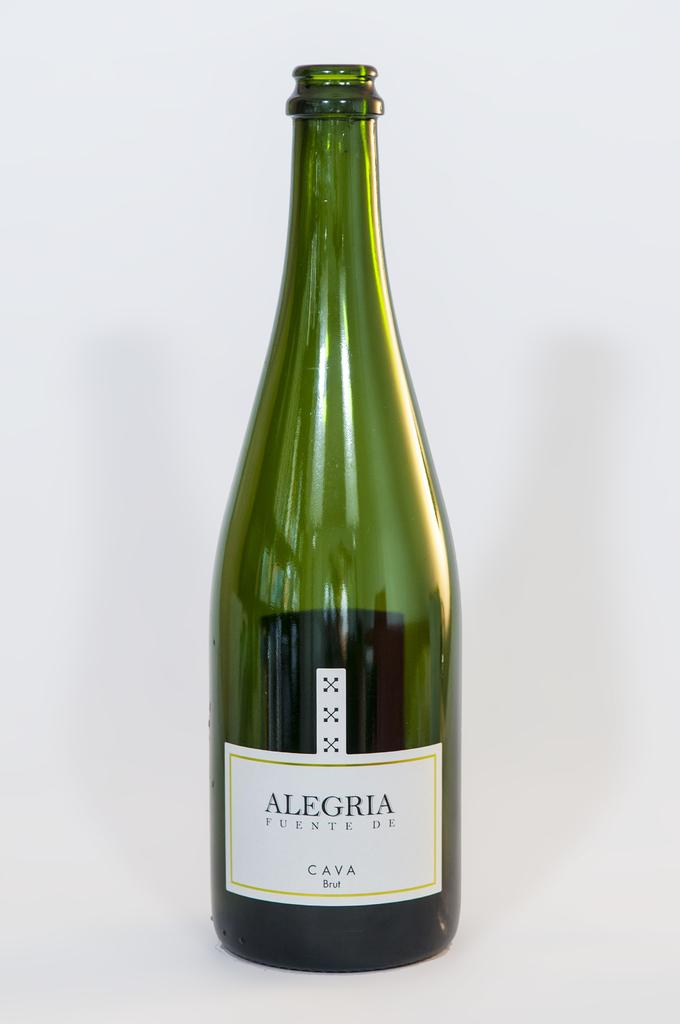<image>
Create a compact narrative representing the image presented. An Alegria bottle that is green in color 